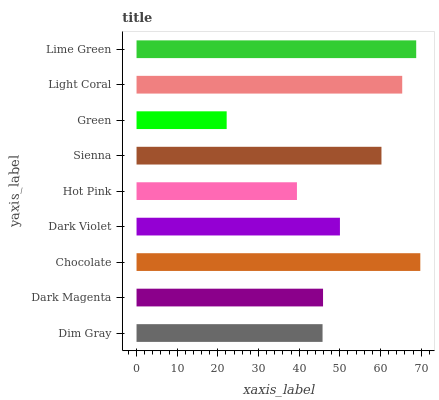Is Green the minimum?
Answer yes or no. Yes. Is Chocolate the maximum?
Answer yes or no. Yes. Is Dark Magenta the minimum?
Answer yes or no. No. Is Dark Magenta the maximum?
Answer yes or no. No. Is Dark Magenta greater than Dim Gray?
Answer yes or no. Yes. Is Dim Gray less than Dark Magenta?
Answer yes or no. Yes. Is Dim Gray greater than Dark Magenta?
Answer yes or no. No. Is Dark Magenta less than Dim Gray?
Answer yes or no. No. Is Dark Violet the high median?
Answer yes or no. Yes. Is Dark Violet the low median?
Answer yes or no. Yes. Is Dim Gray the high median?
Answer yes or no. No. Is Hot Pink the low median?
Answer yes or no. No. 